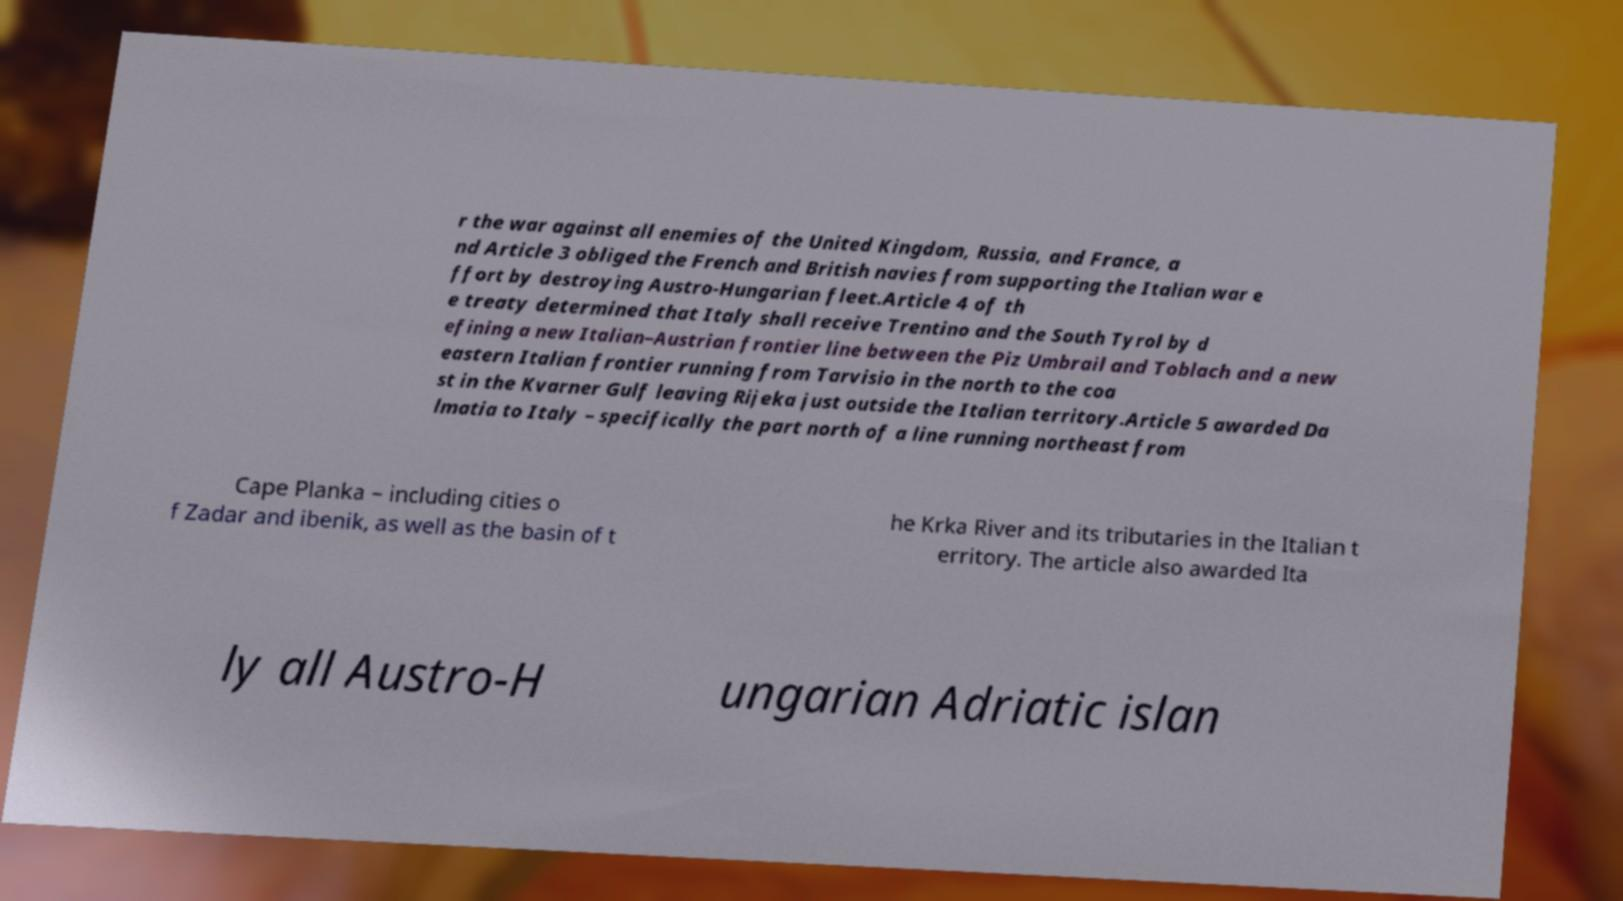What messages or text are displayed in this image? I need them in a readable, typed format. r the war against all enemies of the United Kingdom, Russia, and France, a nd Article 3 obliged the French and British navies from supporting the Italian war e ffort by destroying Austro-Hungarian fleet.Article 4 of th e treaty determined that Italy shall receive Trentino and the South Tyrol by d efining a new Italian–Austrian frontier line between the Piz Umbrail and Toblach and a new eastern Italian frontier running from Tarvisio in the north to the coa st in the Kvarner Gulf leaving Rijeka just outside the Italian territory.Article 5 awarded Da lmatia to Italy – specifically the part north of a line running northeast from Cape Planka – including cities o f Zadar and ibenik, as well as the basin of t he Krka River and its tributaries in the Italian t erritory. The article also awarded Ita ly all Austro-H ungarian Adriatic islan 